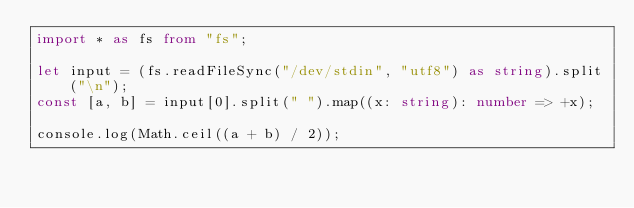Convert code to text. <code><loc_0><loc_0><loc_500><loc_500><_TypeScript_>import * as fs from "fs";

let input = (fs.readFileSync("/dev/stdin", "utf8") as string).split("\n");
const [a, b] = input[0].split(" ").map((x: string): number => +x);

console.log(Math.ceil((a + b) / 2));
</code> 